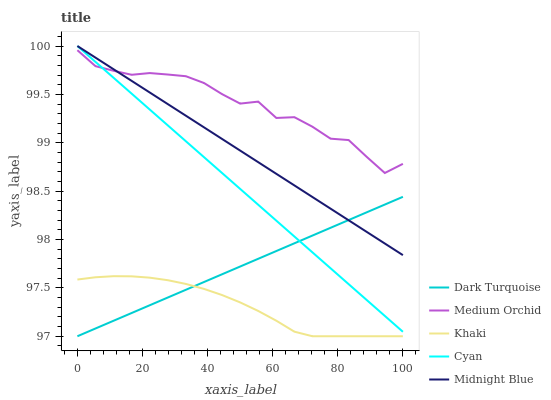Does Khaki have the minimum area under the curve?
Answer yes or no. Yes. Does Medium Orchid have the maximum area under the curve?
Answer yes or no. Yes. Does Medium Orchid have the minimum area under the curve?
Answer yes or no. No. Does Khaki have the maximum area under the curve?
Answer yes or no. No. Is Midnight Blue the smoothest?
Answer yes or no. Yes. Is Medium Orchid the roughest?
Answer yes or no. Yes. Is Khaki the smoothest?
Answer yes or no. No. Is Khaki the roughest?
Answer yes or no. No. Does Dark Turquoise have the lowest value?
Answer yes or no. Yes. Does Medium Orchid have the lowest value?
Answer yes or no. No. Does Cyan have the highest value?
Answer yes or no. Yes. Does Medium Orchid have the highest value?
Answer yes or no. No. Is Dark Turquoise less than Medium Orchid?
Answer yes or no. Yes. Is Midnight Blue greater than Khaki?
Answer yes or no. Yes. Does Midnight Blue intersect Medium Orchid?
Answer yes or no. Yes. Is Midnight Blue less than Medium Orchid?
Answer yes or no. No. Is Midnight Blue greater than Medium Orchid?
Answer yes or no. No. Does Dark Turquoise intersect Medium Orchid?
Answer yes or no. No. 